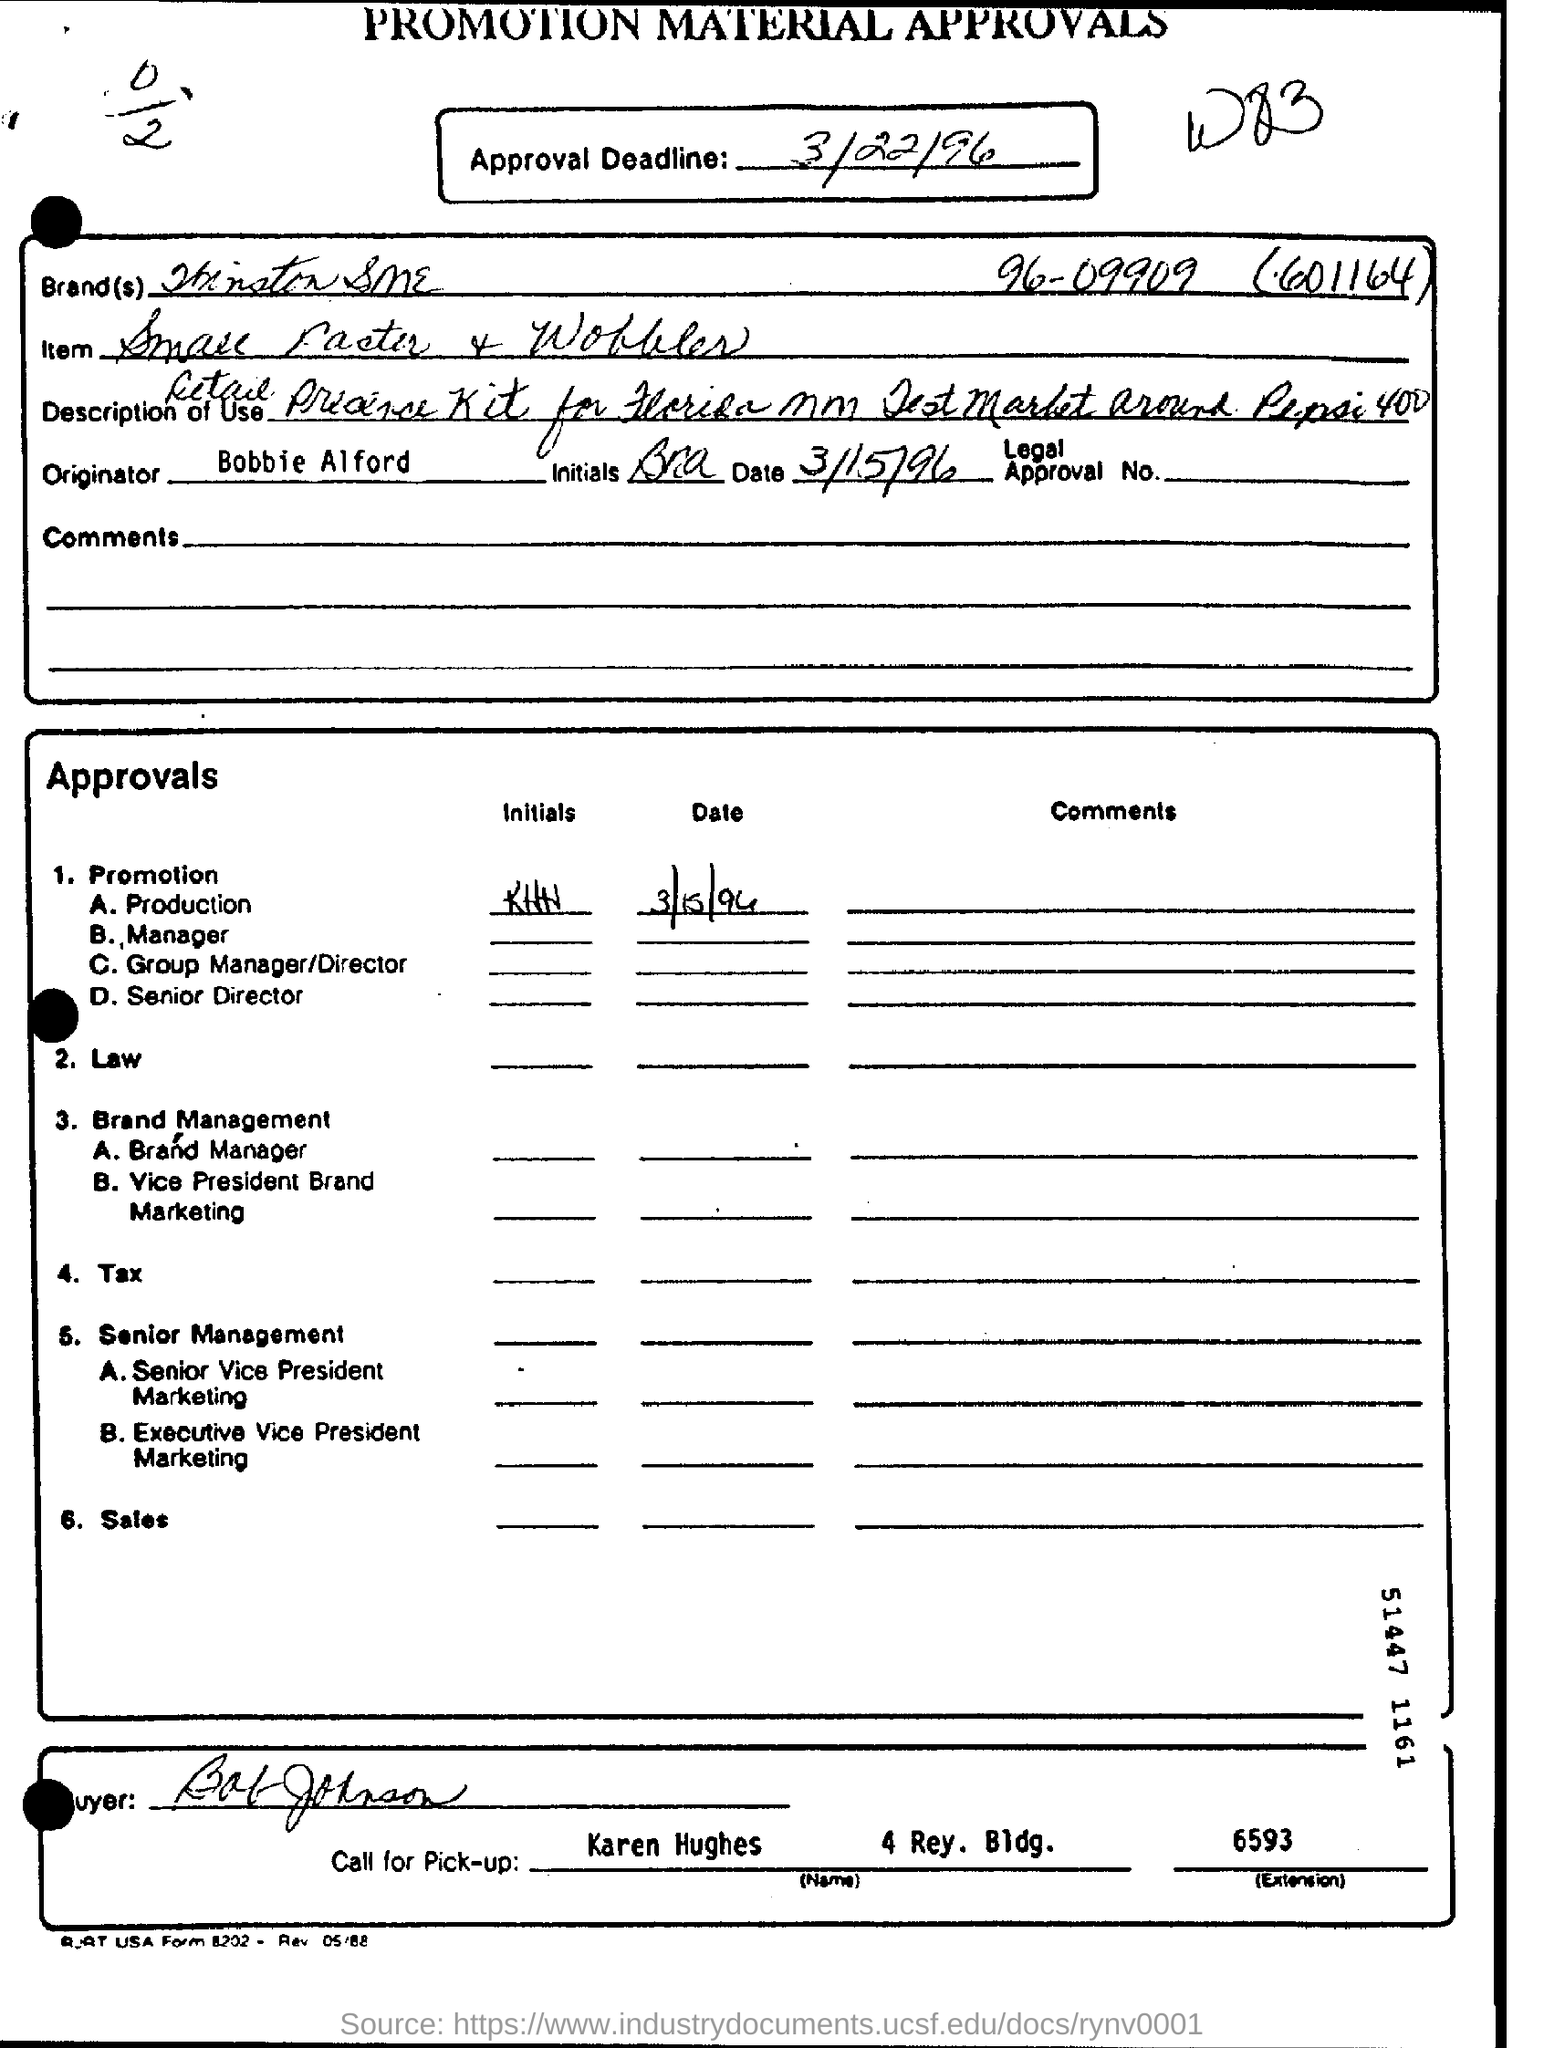Mention a couple of crucial points in this snapshot. The extension number of Karen Hughes is 6593. One should call Karen Hughes for pick up. The approval deadline is March 22, 1996. The originator is Bobbie Alford. 